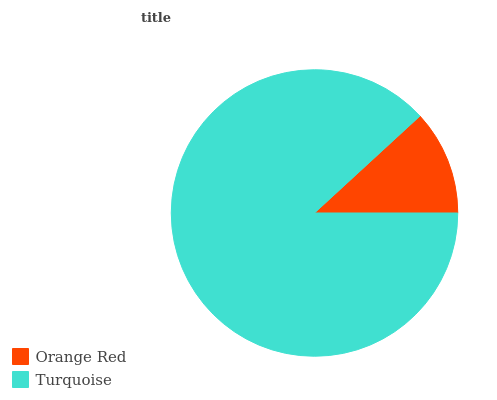Is Orange Red the minimum?
Answer yes or no. Yes. Is Turquoise the maximum?
Answer yes or no. Yes. Is Turquoise the minimum?
Answer yes or no. No. Is Turquoise greater than Orange Red?
Answer yes or no. Yes. Is Orange Red less than Turquoise?
Answer yes or no. Yes. Is Orange Red greater than Turquoise?
Answer yes or no. No. Is Turquoise less than Orange Red?
Answer yes or no. No. Is Turquoise the high median?
Answer yes or no. Yes. Is Orange Red the low median?
Answer yes or no. Yes. Is Orange Red the high median?
Answer yes or no. No. Is Turquoise the low median?
Answer yes or no. No. 